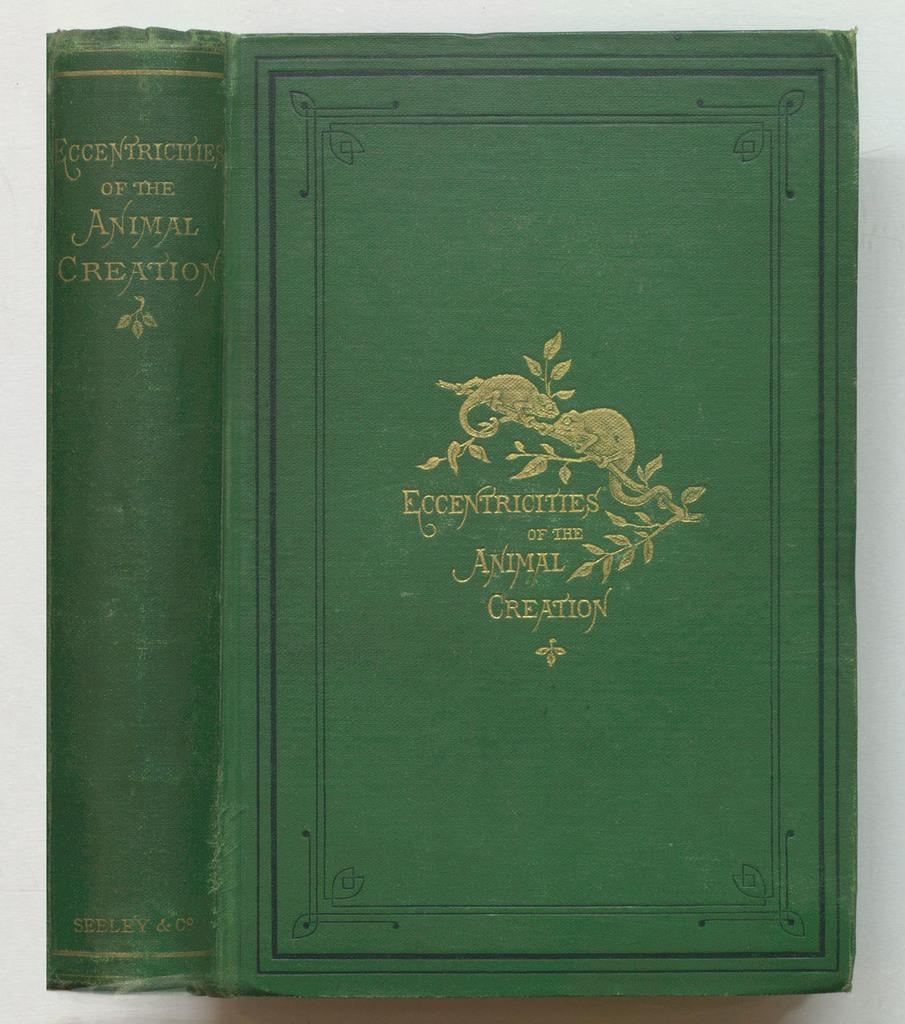<image>
Relay a brief, clear account of the picture shown. the word creation is at the end of a book 